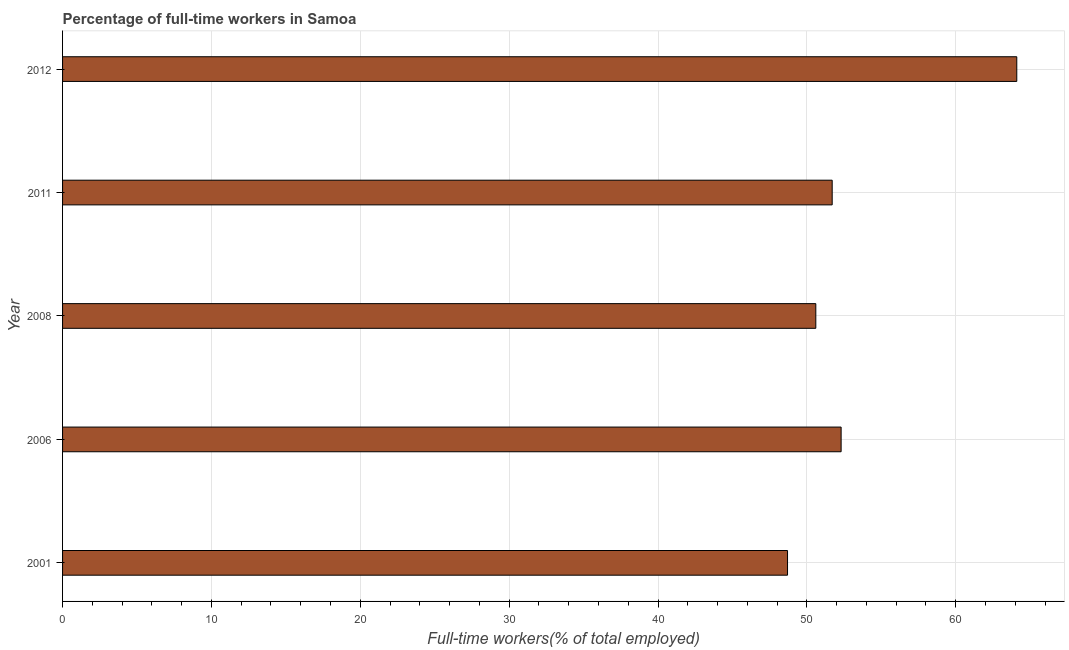Does the graph contain any zero values?
Your answer should be very brief. No. Does the graph contain grids?
Keep it short and to the point. Yes. What is the title of the graph?
Your answer should be very brief. Percentage of full-time workers in Samoa. What is the label or title of the X-axis?
Provide a short and direct response. Full-time workers(% of total employed). What is the label or title of the Y-axis?
Ensure brevity in your answer.  Year. What is the percentage of full-time workers in 2001?
Make the answer very short. 48.7. Across all years, what is the maximum percentage of full-time workers?
Offer a very short reply. 64.1. Across all years, what is the minimum percentage of full-time workers?
Offer a very short reply. 48.7. In which year was the percentage of full-time workers maximum?
Provide a succinct answer. 2012. In which year was the percentage of full-time workers minimum?
Make the answer very short. 2001. What is the sum of the percentage of full-time workers?
Offer a very short reply. 267.4. What is the difference between the percentage of full-time workers in 2008 and 2012?
Keep it short and to the point. -13.5. What is the average percentage of full-time workers per year?
Make the answer very short. 53.48. What is the median percentage of full-time workers?
Provide a succinct answer. 51.7. Do a majority of the years between 2006 and 2011 (inclusive) have percentage of full-time workers greater than 54 %?
Keep it short and to the point. No. What is the ratio of the percentage of full-time workers in 2001 to that in 2011?
Make the answer very short. 0.94. Is the percentage of full-time workers in 2001 less than that in 2008?
Give a very brief answer. Yes. What is the difference between the highest and the second highest percentage of full-time workers?
Offer a terse response. 11.8. Is the sum of the percentage of full-time workers in 2006 and 2008 greater than the maximum percentage of full-time workers across all years?
Keep it short and to the point. Yes. In how many years, is the percentage of full-time workers greater than the average percentage of full-time workers taken over all years?
Keep it short and to the point. 1. How many bars are there?
Your answer should be very brief. 5. How many years are there in the graph?
Offer a very short reply. 5. What is the Full-time workers(% of total employed) in 2001?
Make the answer very short. 48.7. What is the Full-time workers(% of total employed) of 2006?
Your response must be concise. 52.3. What is the Full-time workers(% of total employed) of 2008?
Keep it short and to the point. 50.6. What is the Full-time workers(% of total employed) in 2011?
Ensure brevity in your answer.  51.7. What is the Full-time workers(% of total employed) of 2012?
Give a very brief answer. 64.1. What is the difference between the Full-time workers(% of total employed) in 2001 and 2006?
Give a very brief answer. -3.6. What is the difference between the Full-time workers(% of total employed) in 2001 and 2011?
Provide a short and direct response. -3. What is the difference between the Full-time workers(% of total employed) in 2001 and 2012?
Make the answer very short. -15.4. What is the difference between the Full-time workers(% of total employed) in 2006 and 2011?
Keep it short and to the point. 0.6. What is the difference between the Full-time workers(% of total employed) in 2008 and 2011?
Ensure brevity in your answer.  -1.1. What is the difference between the Full-time workers(% of total employed) in 2008 and 2012?
Offer a terse response. -13.5. What is the difference between the Full-time workers(% of total employed) in 2011 and 2012?
Your answer should be compact. -12.4. What is the ratio of the Full-time workers(% of total employed) in 2001 to that in 2008?
Ensure brevity in your answer.  0.96. What is the ratio of the Full-time workers(% of total employed) in 2001 to that in 2011?
Make the answer very short. 0.94. What is the ratio of the Full-time workers(% of total employed) in 2001 to that in 2012?
Your answer should be very brief. 0.76. What is the ratio of the Full-time workers(% of total employed) in 2006 to that in 2008?
Your answer should be compact. 1.03. What is the ratio of the Full-time workers(% of total employed) in 2006 to that in 2012?
Make the answer very short. 0.82. What is the ratio of the Full-time workers(% of total employed) in 2008 to that in 2012?
Offer a very short reply. 0.79. What is the ratio of the Full-time workers(% of total employed) in 2011 to that in 2012?
Ensure brevity in your answer.  0.81. 